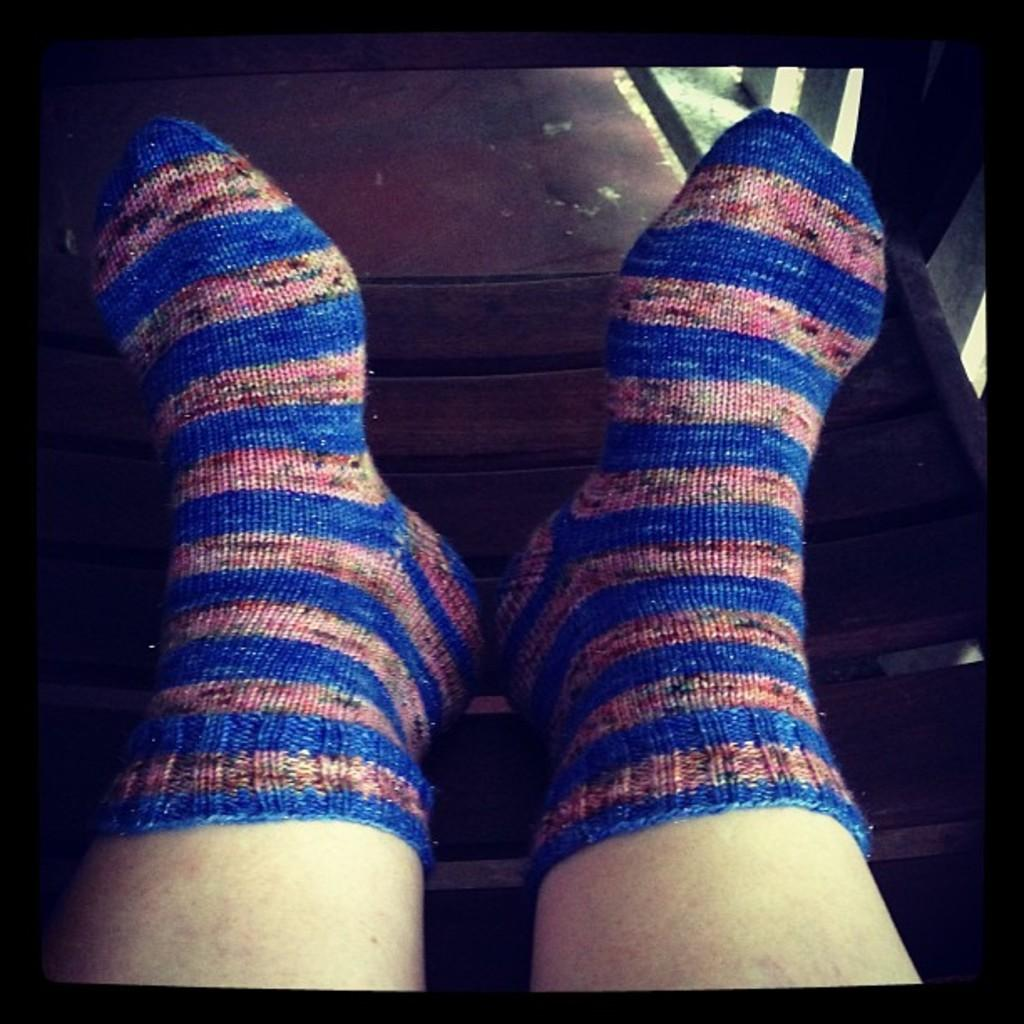What body part is visible in the image? There are a person's legs with socks in the image. What is the legs resting on in the image? The legs are on a wooden platform. What type of vegetation can be seen in the background of the image? There is grass visible in the background of the image. What type of toothbrush is being used to exchange information with the cart in the image? There is no toothbrush, exchange of information, or cart present in the image. 